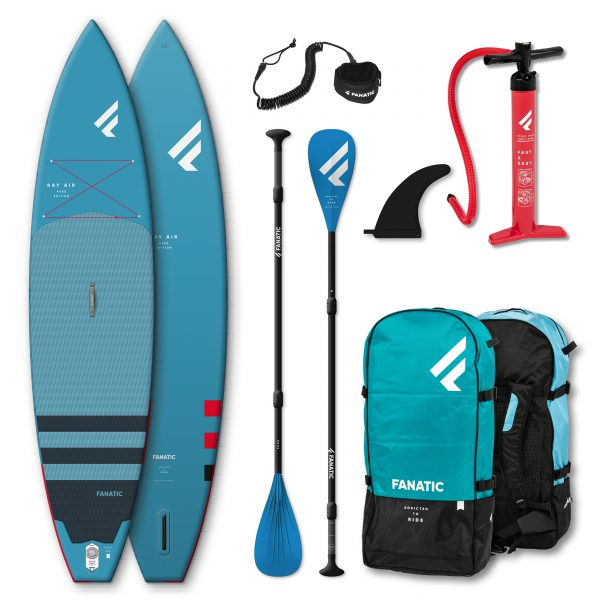If someone planned to paddleboard solo in a remote location, what additional items might they need beyond what is pictured? For a solo paddleboarding trip in a remote location, it would be wise to include a personal flotation device (PFD), a whistle for attracting attention in case of emergency, a waterproof phone case, GPS or a compass for navigation, plenty of water, sun protection (hat, sunscreen, sunglasses), and possibly a small first aid kit. If paddling in waters with boat traffic or in low-light conditions, navigation lights would also be very useful. Do you think adding a waterproof bag would be beneficial, and why? Absolutely. A waterproof bag would be highly beneficial as it allows you to keep your personal belongings dry, including your phone, wallet, keys, and any other essentials. It provides peace of mind knowing your items are protected from water damage while you focus on enjoying your paddleboarding adventure. 